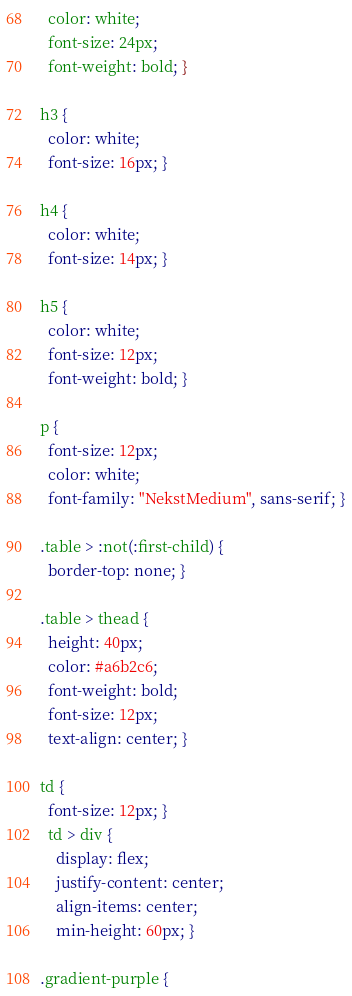<code> <loc_0><loc_0><loc_500><loc_500><_CSS_>  color: white;
  font-size: 24px;
  font-weight: bold; }

h3 {
  color: white;
  font-size: 16px; }

h4 {
  color: white;
  font-size: 14px; }

h5 {
  color: white;
  font-size: 12px;
  font-weight: bold; }

p {
  font-size: 12px;
  color: white;
  font-family: "NekstMedium", sans-serif; }

.table > :not(:first-child) {
  border-top: none; }

.table > thead {
  height: 40px;
  color: #a6b2c6;
  font-weight: bold;
  font-size: 12px;
  text-align: center; }

td {
  font-size: 12px; }
  td > div {
    display: flex;
    justify-content: center;
    align-items: center;
    min-height: 60px; }

.gradient-purple {</code> 